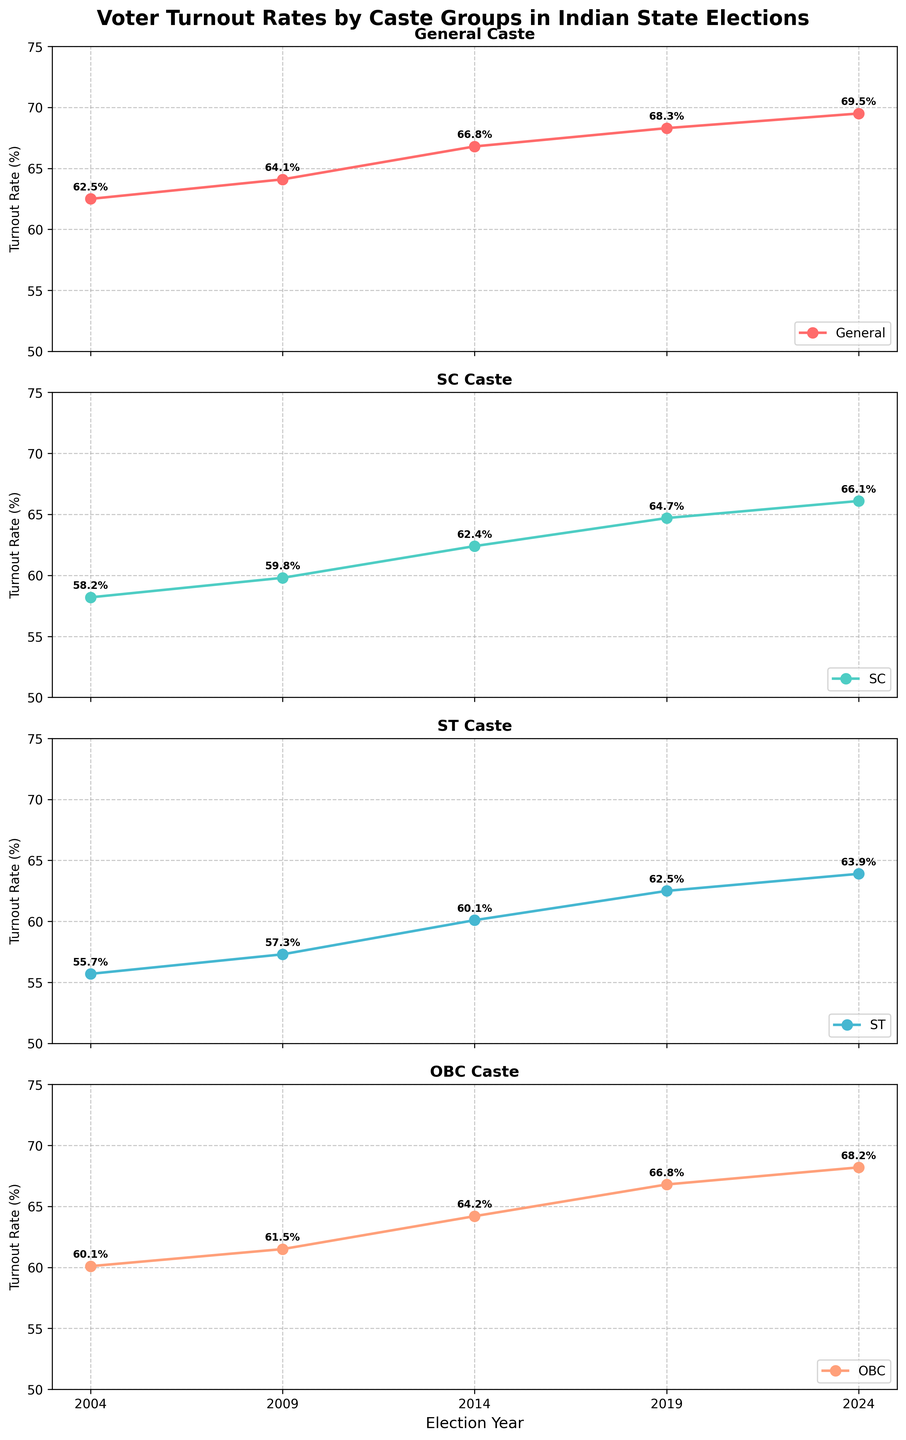What is the overall trend in voter turnout rates for the General caste group from 2004 to 2024? To determine the trend, observe the points for the General caste over the years on the plot. The turnout rate starts at 62.5% in 2004 and increases steadily to 69.5% in 2024. This indicates a rising trend.
Answer: Increasing Which caste group had the highest voter turnout rate in 2014? Compare the turnout rates for all caste groups (General, SC, ST, OBC) in the year 2014 on the plotted lines. General caste had a turnout of 66.8%, SC 62.4%, ST 60.1%, and OBC 64.2%. Thus, the General caste had the highest turnout.
Answer: General In which year did the SC caste group have its smallest increase in turnout rate compared to the previous election? Calculate the differences between consecutive years for the SC caste group: 2009 over 2004 (1.6%), 2014 over 2009 (2.6%), 2019 over 2014 (2.3%), and 2024 over 2019 (1.4%). The smallest increase occurs from 2019 to 2024.
Answer: 2024 How much did the voter turnout rate for the ST caste group change from 2004 to 2024? Subtract the 2004 turnout rate for the ST group (55.7%) from the 2024 turnout rate (63.9%). The change is 63.9% - 55.7% = 8.2%.
Answer: 8.2% Which caste group's voter turnout rate had the least variability over the five elections? Compare the range (difference between max and min values) of turnout rates for each caste group. General: (69.5%-62.5%=7%), SC: (66.1%-58.2%=7.9%), ST: (63.9%-55.7%=8.2%), OBC: (68.2%-60.1%=8.1%). The General caste shows the least variability.
Answer: General What year did the OBC caste group surpass a 65% voter turnout rate? Look at the y-axis values for the OBC line and find the first year when the turnout rate exceeds 65%. This occurs in 2019 with a turnout rate of 66.8%.
Answer: 2019 Between which consecutive elections did the General caste group see the largest increase in their voter turnout rate? Calculate the differences for consecutive years: 2009-2004 (1.6%), 2014-2009 (2.7%), 2019-2014 (1.5%), 2024-2019 (1.2%). The largest increase is from 2009 to 2014 (2.7%).
Answer: Between 2009 and 2014 